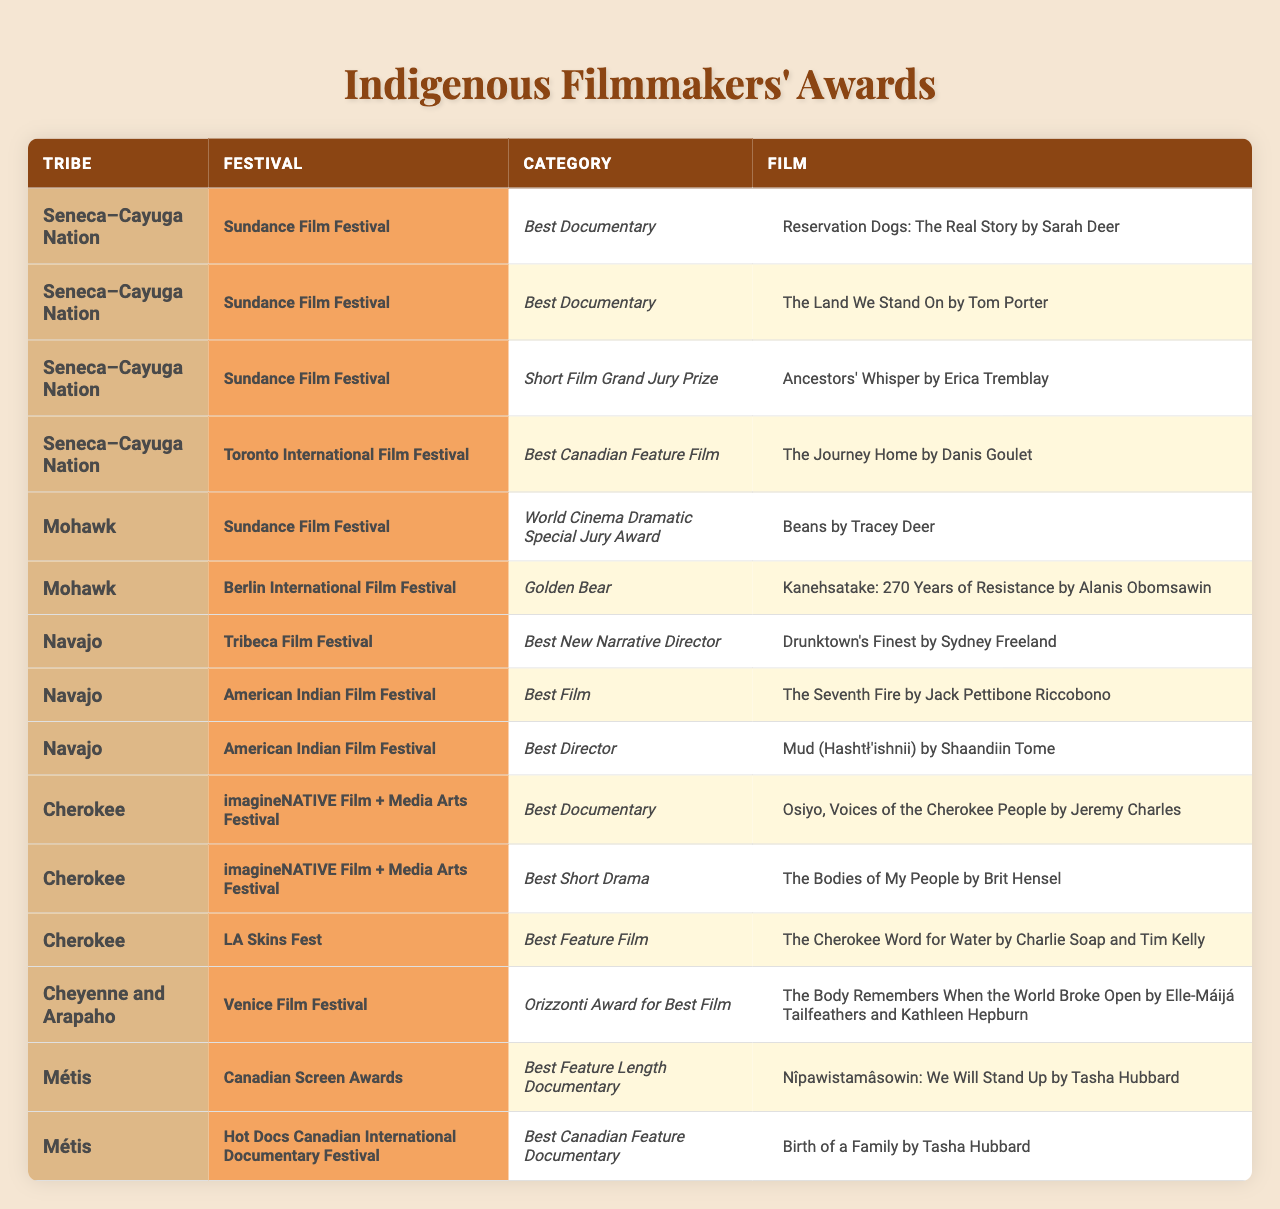What is the title of the Best Documentary award won by a Seneca-Cayuga filmmaker at the Sundance Film Festival? According to the table, the Best Documentary award won by a Seneca-Cayuga filmmaker at the Sundance Film Festival includes "Reservation Dogs: The Real Story by Sarah Deer" and "The Land We Stand On by Tom Porter."
Answer: "Reservation Dogs: The Real Story by Sarah Deer" and "The Land We Stand On by Tom Porter" How many award categories were won by Navajo filmmakers at the American Indian Film Festival? The table shows that Navajo filmmakers won two categories at the American Indian Film Festival: Best Film and Best Director. Therefore, the number of categories is two.
Answer: 2 Did any Mohawk filmmaker win an award at the Berlin International Film Festival? Yes, the table indicates that a Mohawk filmmaker won the Golden Bear at the Berlin International Film Festival for "Kanehsatake: 270 Years of Resistance by Alanis Obomsawin."
Answer: Yes Which tribe had a film that won the Best Feature Length Documentary at the Canadian Screen Awards? The table indicates that the Métis tribe had a film that won the Best Feature Length Documentary at the Canadian Screen Awards titled "Nîpawistamâsowin: We Will Stand Up by Tasha Hubbard."
Answer: Métis What is the total number of film awards won by Cherokee filmmakers at the imagineNATIVE Film + Media Arts Festival? At the imagineNATIVE Film + Media Arts Festival, Cherokee filmmakers won two awards: Best Documentary and Best Short Drama. Therefore, the total number of awards is two.
Answer: 2 Which Indigenous filmmaker received an award for Best New Narrative Director at the Tribeca Film Festival? The table shows that the award for Best New Narrative Director at the Tribeca Film Festival was won by Sydney Freeland for "Drunktown's Finest."
Answer: Sydney Freeland How many festivals awarded films directed by Cheyenne and Arapaho filmmakers? According to the data, films directed by Cheyenne and Arapaho filmmakers received an award only at the Venice Film Festival, which makes it one festival.
Answer: 1 Which award category won by Indigenous filmmakers has the most entries listed in the table? The table indicates that the Best Documentary award has multiple entries from different tribes. The entries for the Best Documentary award include one from the Seneca-Cayuga and one from the Cherokee.
Answer: Best Documentary Are there more film awards won by filmmakers from the Seneca-Cayuga Nation than from the Mohawk tribe? Yes, the table shows that filmmakers from the Seneca-Cayuga Nation won three awards across different categories, while Mohawk filmmakers won only two awards, indicating Seneca-Cayuga filmmakers have more awards.
Answer: Yes What is the award title for the film "The Body Remembers When the World Broke Open"? The film "The Body Remembers When the World Broke Open" won the Orizzonti Award for Best Film at the Venice Film Festival, according to the table.
Answer: Orizzonti Award for Best Film 